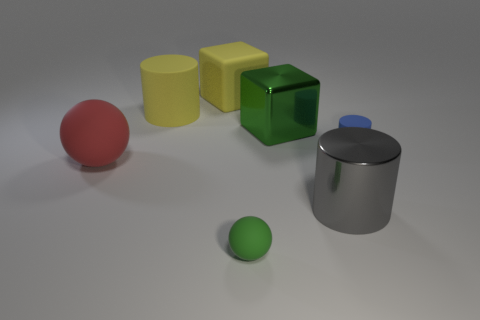Is the big green object made of the same material as the block that is left of the small green thing?
Your response must be concise. No. How many cyan objects are either large rubber blocks or tiny matte objects?
Ensure brevity in your answer.  0. The green sphere that is made of the same material as the small blue thing is what size?
Your response must be concise. Small. What number of large red rubber things have the same shape as the large green shiny object?
Provide a short and direct response. 0. Are there more matte balls in front of the large green metal cube than blocks that are on the right side of the tiny blue cylinder?
Your answer should be very brief. Yes. There is a big matte cylinder; does it have the same color as the big block that is behind the big green thing?
Provide a succinct answer. Yes. What material is the other cylinder that is the same size as the gray cylinder?
Offer a very short reply. Rubber. What number of things are either small cyan blocks or blue matte objects behind the red matte ball?
Offer a very short reply. 1. Does the matte block have the same size as the green object that is on the right side of the tiny rubber sphere?
Provide a short and direct response. Yes. How many blocks are gray objects or big things?
Provide a succinct answer. 2. 